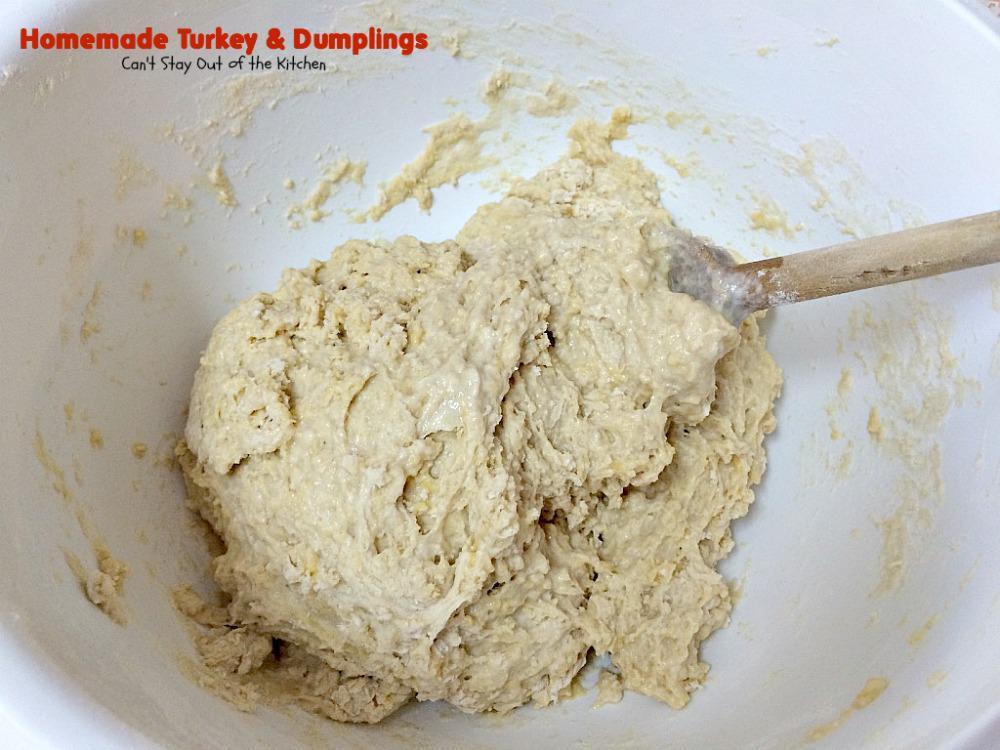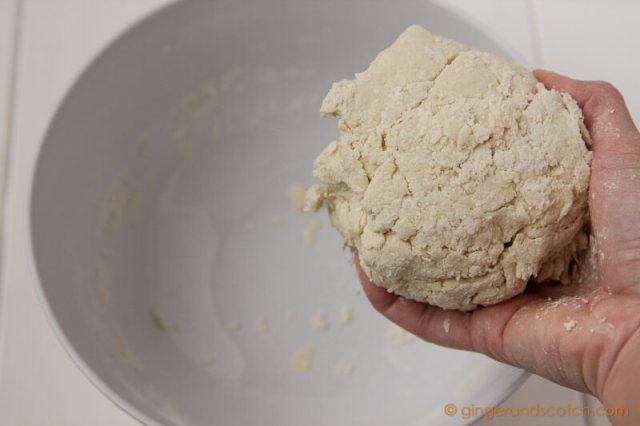The first image is the image on the left, the second image is the image on the right. Examine the images to the left and right. Is the description "An image contains a human hand touching a mound of dough." accurate? Answer yes or no. Yes. The first image is the image on the left, the second image is the image on the right. For the images shown, is this caption "Dough and flour are on a wooden cutting board." true? Answer yes or no. No. 